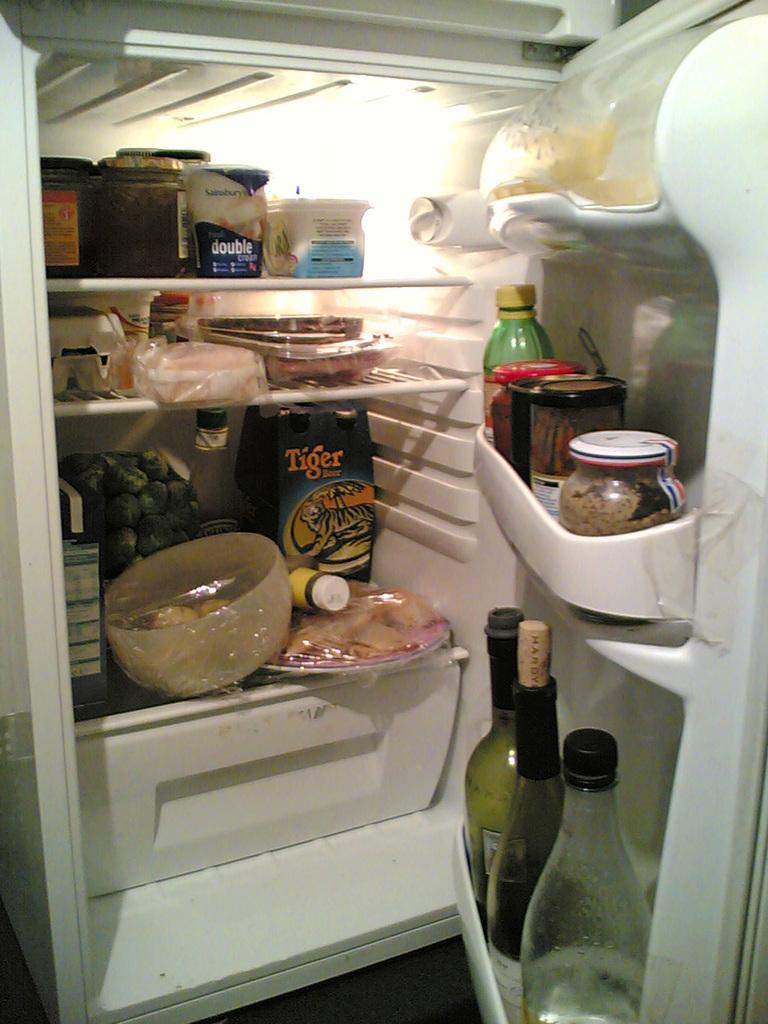What appliance can be seen in the image? There is a refrigerator in the image. What is the state of the refrigerator door? The refrigerator door is open. How are the food items arranged in the refrigerator? The food items are on different floors of the refrigerator. What type of items can be seen in the door of the refrigerator? There are bottles in the door of the refrigerator. How does the refrigerator contribute to pollution in the image? The image does not provide any information about pollution, and the refrigerator itself does not contribute to pollution in the image. 